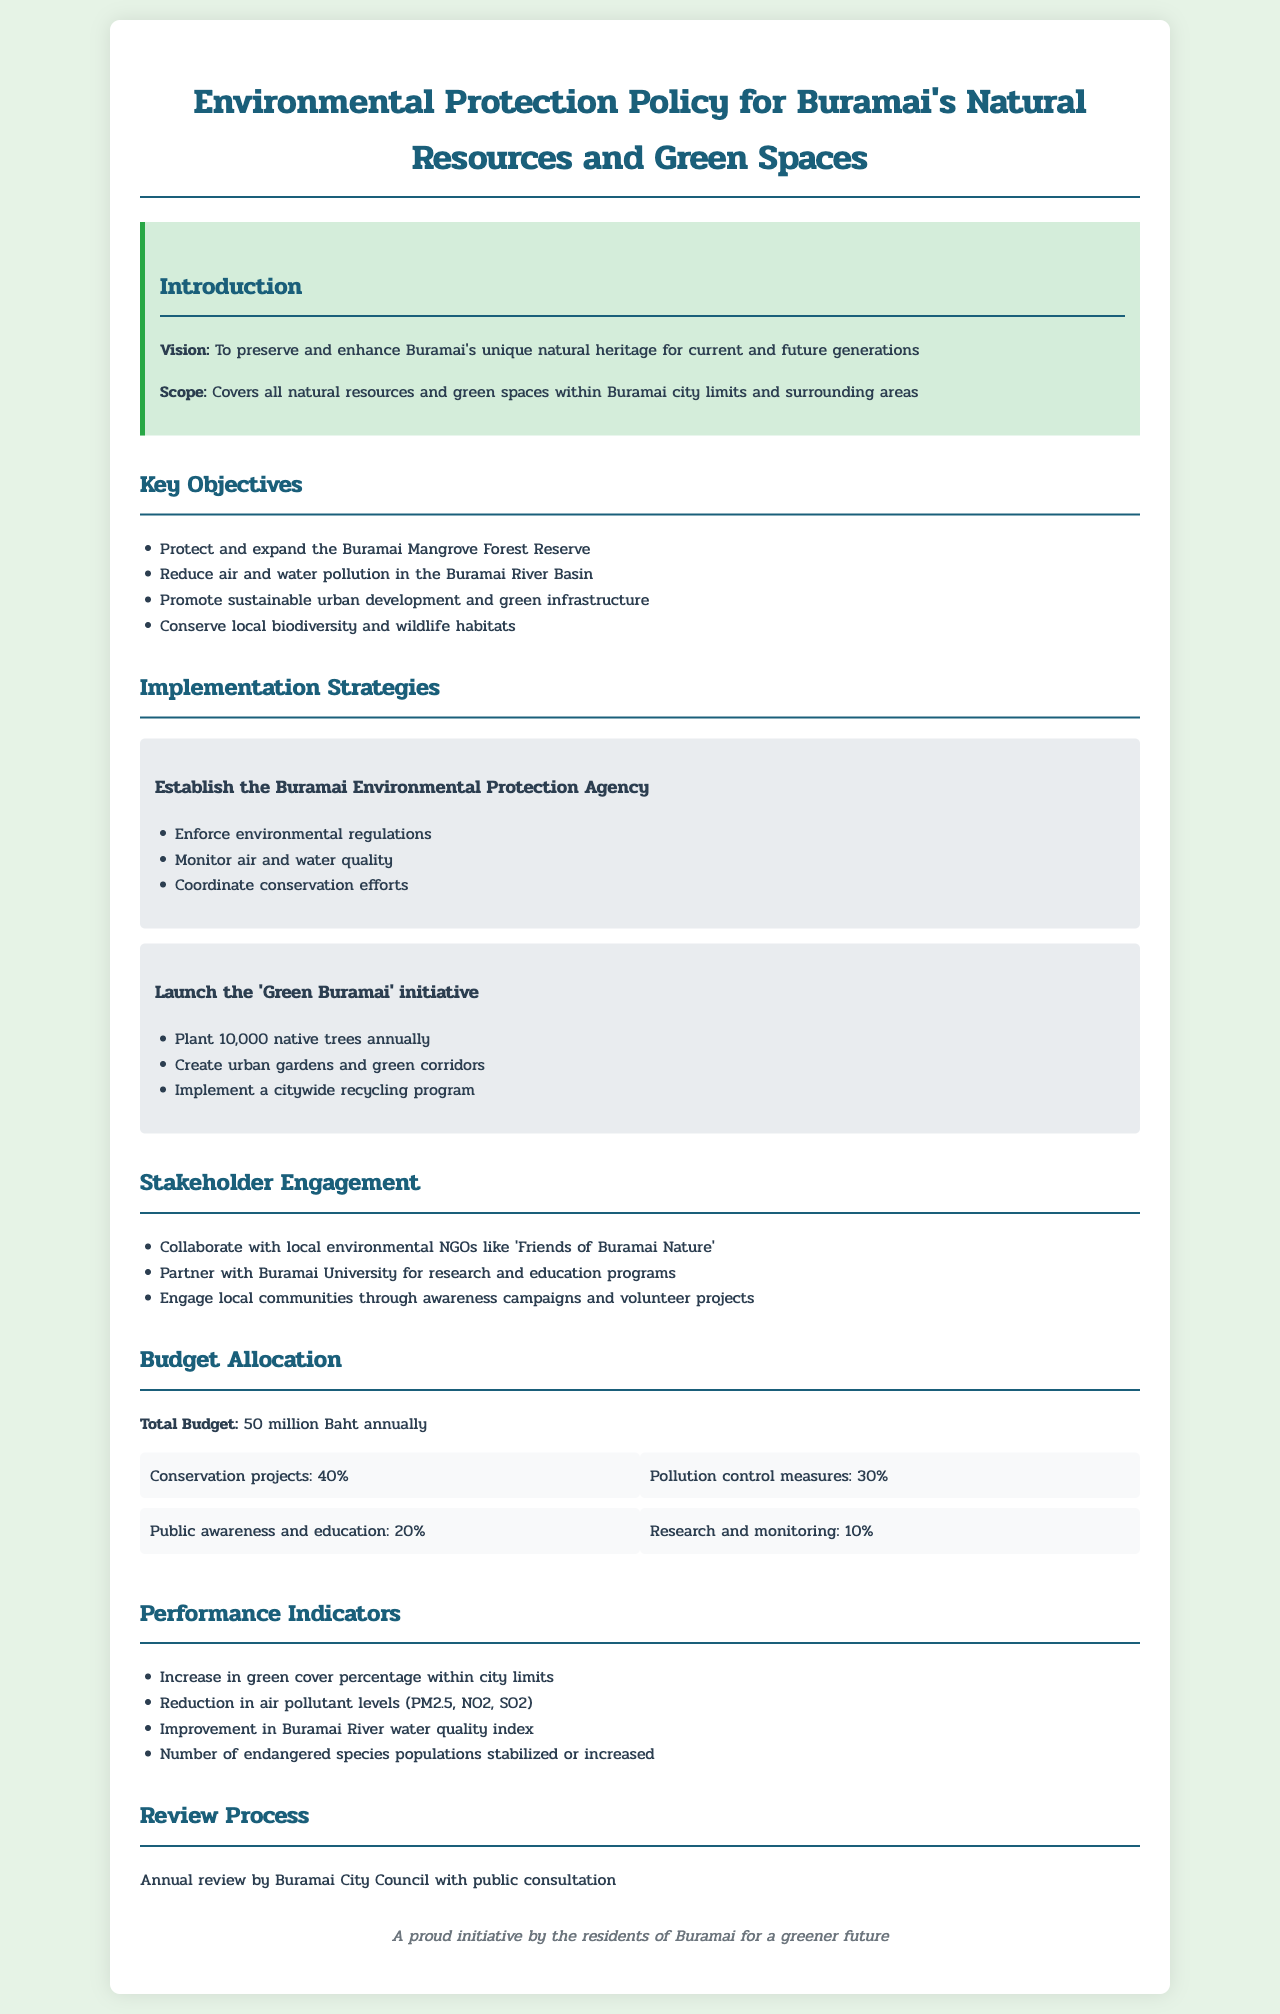What is the vision of the policy? The vision is to preserve and enhance Buramai's unique natural heritage for current and future generations.
Answer: To preserve and enhance Buramai's unique natural heritage for current and future generations What is the total budget allocated annually? The total budget is explicitly stated in the document as 50 million Baht annually.
Answer: 50 million Baht What percentage of the budget is allocated for conservation projects? The document specifies that 40% of the total budget is allocated for conservation projects.
Answer: 40% Which initiative aims to plant native trees? The 'Green Buramai' initiative is responsible for planting native trees annually.
Answer: 'Green Buramai' initiative What are the performance indicators aimed at measuring? The performance indicators measure improvements in green cover, air quality, water quality, and wildlife populations.
Answer: Improvements in green cover, air quality, water quality, and wildlife populations What organization is suggested to collaborate with for research programs? The document suggests partnering with Buramai University for research and education programs.
Answer: Buramai University How often will the review process occur? The review process is set to occur annually as mentioned in the policy document.
Answer: Annually What is one of the objectives related to pollution? One of the objectives is to reduce air and water pollution in the Buramai River Basin.
Answer: Reduce air and water pollution in the Buramai River Basin 